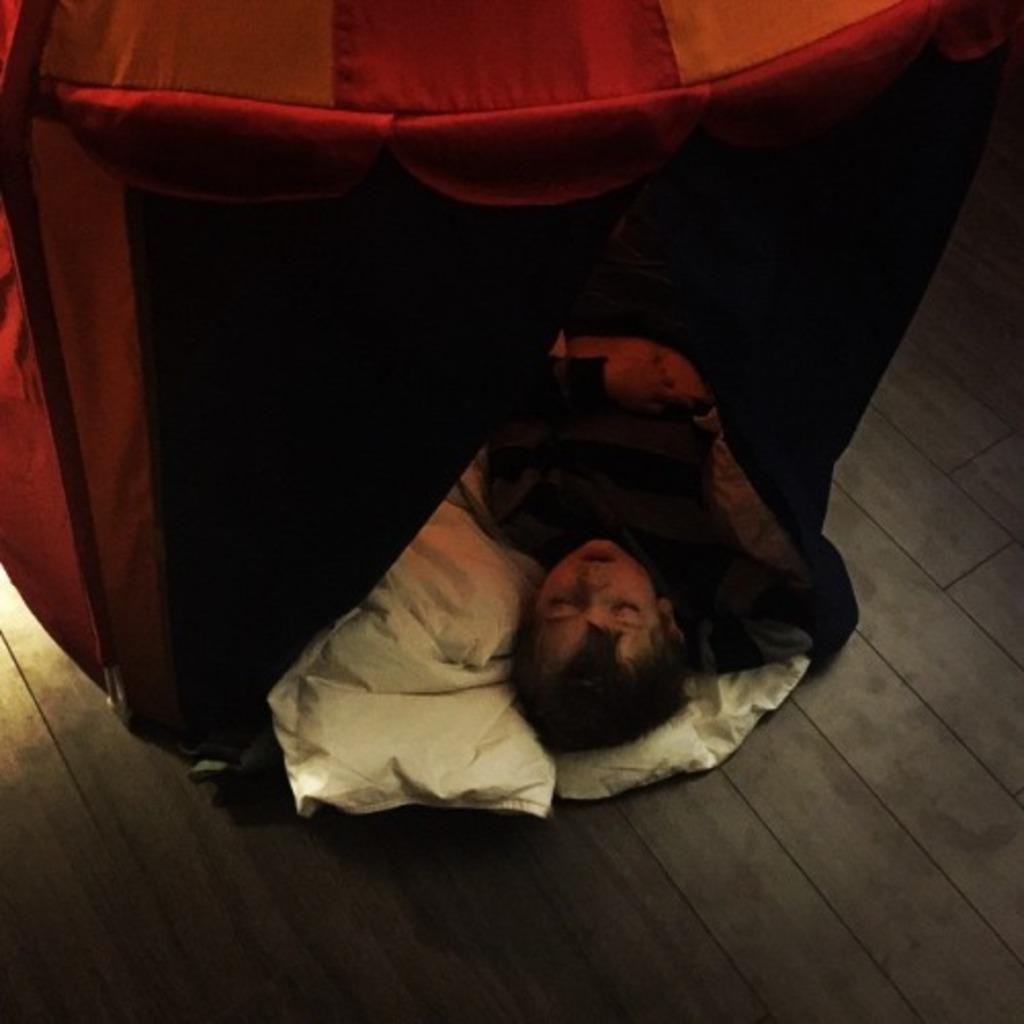How would you summarize this image in a sentence or two? This image consists of a person sleeping on the floor. At the bottom, we can see a white cloth. In the front, it looks like a tent in red color. The floor is made up of wood. 